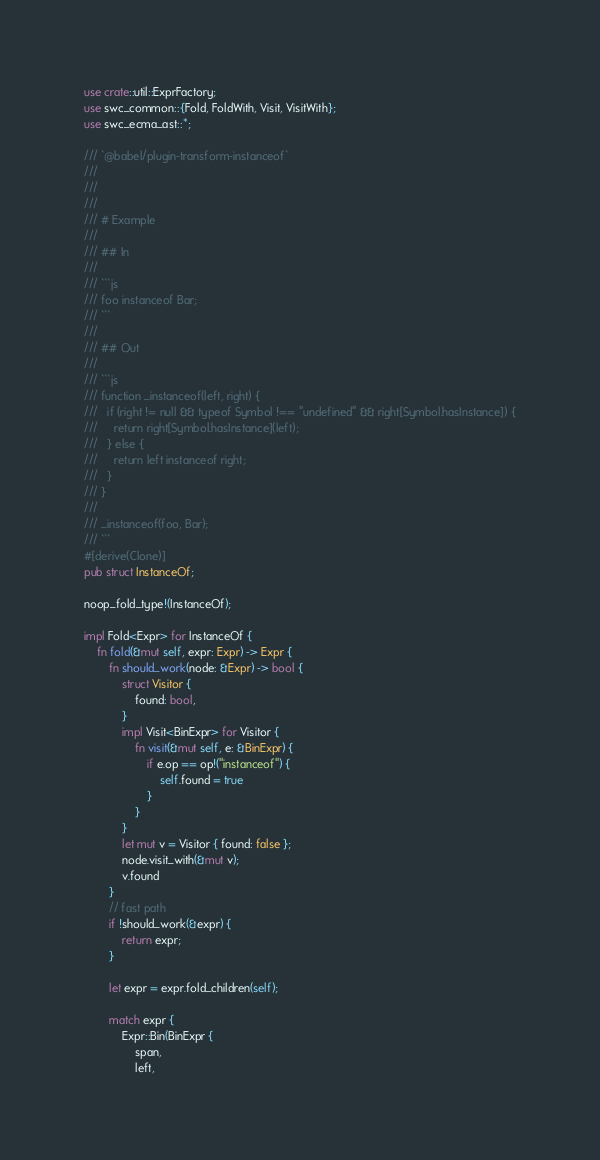Convert code to text. <code><loc_0><loc_0><loc_500><loc_500><_Rust_>use crate::util::ExprFactory;
use swc_common::{Fold, FoldWith, Visit, VisitWith};
use swc_ecma_ast::*;

/// `@babel/plugin-transform-instanceof`
///
///
///
/// # Example
///
/// ## In
///
/// ```js
/// foo instanceof Bar;
/// ```
///
/// ## Out
///
/// ```js
/// function _instanceof(left, right) {
///   if (right != null && typeof Symbol !== "undefined" && right[Symbol.hasInstance]) {
///     return right[Symbol.hasInstance](left);
///   } else {
///     return left instanceof right;
///   }
/// }
///
/// _instanceof(foo, Bar);
/// ```
#[derive(Clone)]
pub struct InstanceOf;

noop_fold_type!(InstanceOf);

impl Fold<Expr> for InstanceOf {
    fn fold(&mut self, expr: Expr) -> Expr {
        fn should_work(node: &Expr) -> bool {
            struct Visitor {
                found: bool,
            }
            impl Visit<BinExpr> for Visitor {
                fn visit(&mut self, e: &BinExpr) {
                    if e.op == op!("instanceof") {
                        self.found = true
                    }
                }
            }
            let mut v = Visitor { found: false };
            node.visit_with(&mut v);
            v.found
        }
        // fast path
        if !should_work(&expr) {
            return expr;
        }

        let expr = expr.fold_children(self);

        match expr {
            Expr::Bin(BinExpr {
                span,
                left,</code> 